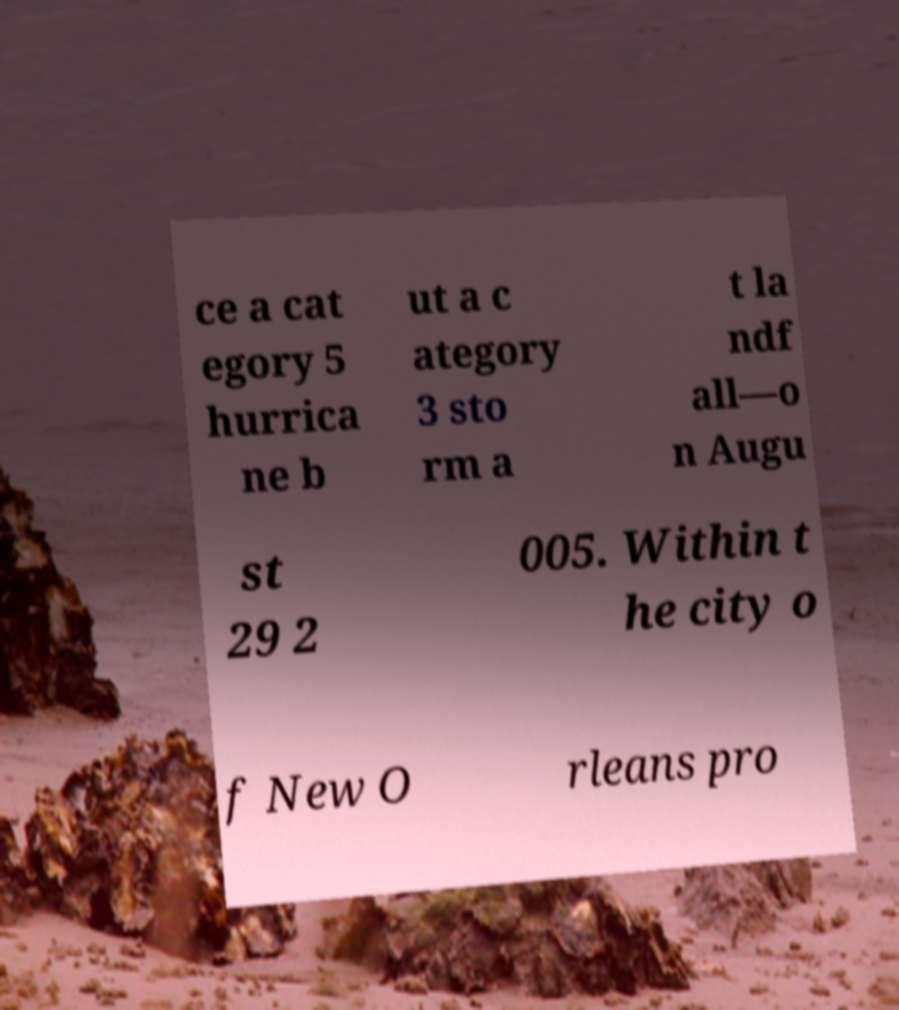Could you extract and type out the text from this image? ce a cat egory 5 hurrica ne b ut a c ategory 3 sto rm a t la ndf all—o n Augu st 29 2 005. Within t he city o f New O rleans pro 